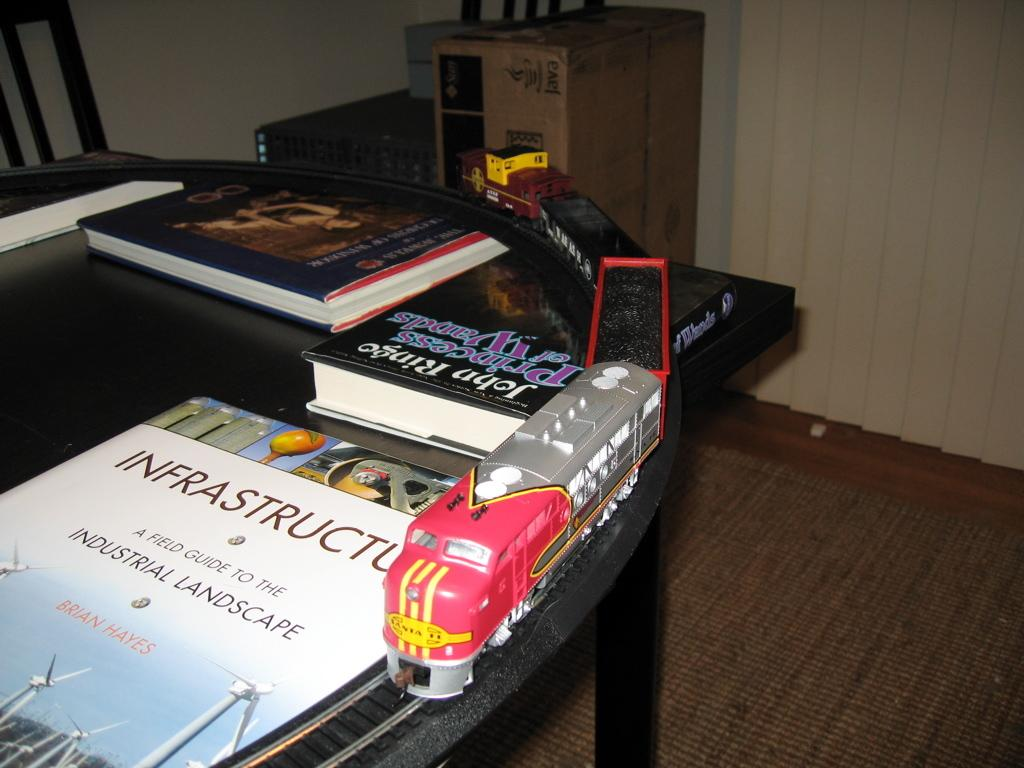<image>
Share a concise interpretation of the image provided. A train is on a table next to several books, one of which is called Infrastructure. 